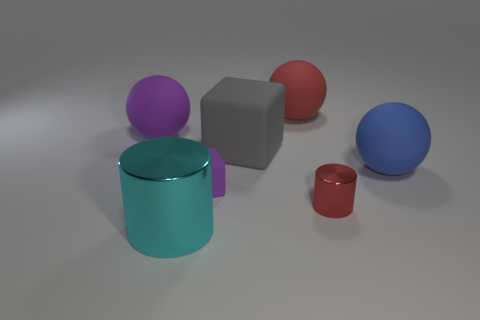Add 2 green matte cylinders. How many objects exist? 9 Subtract all large blue matte spheres. How many spheres are left? 2 Subtract 1 balls. How many balls are left? 2 Add 6 large gray cylinders. How many large gray cylinders exist? 6 Subtract all purple balls. How many balls are left? 2 Subtract 0 red blocks. How many objects are left? 7 Subtract all blocks. How many objects are left? 5 Subtract all purple balls. Subtract all red cubes. How many balls are left? 2 Subtract all tiny brown spheres. Subtract all tiny rubber objects. How many objects are left? 6 Add 2 cyan things. How many cyan things are left? 3 